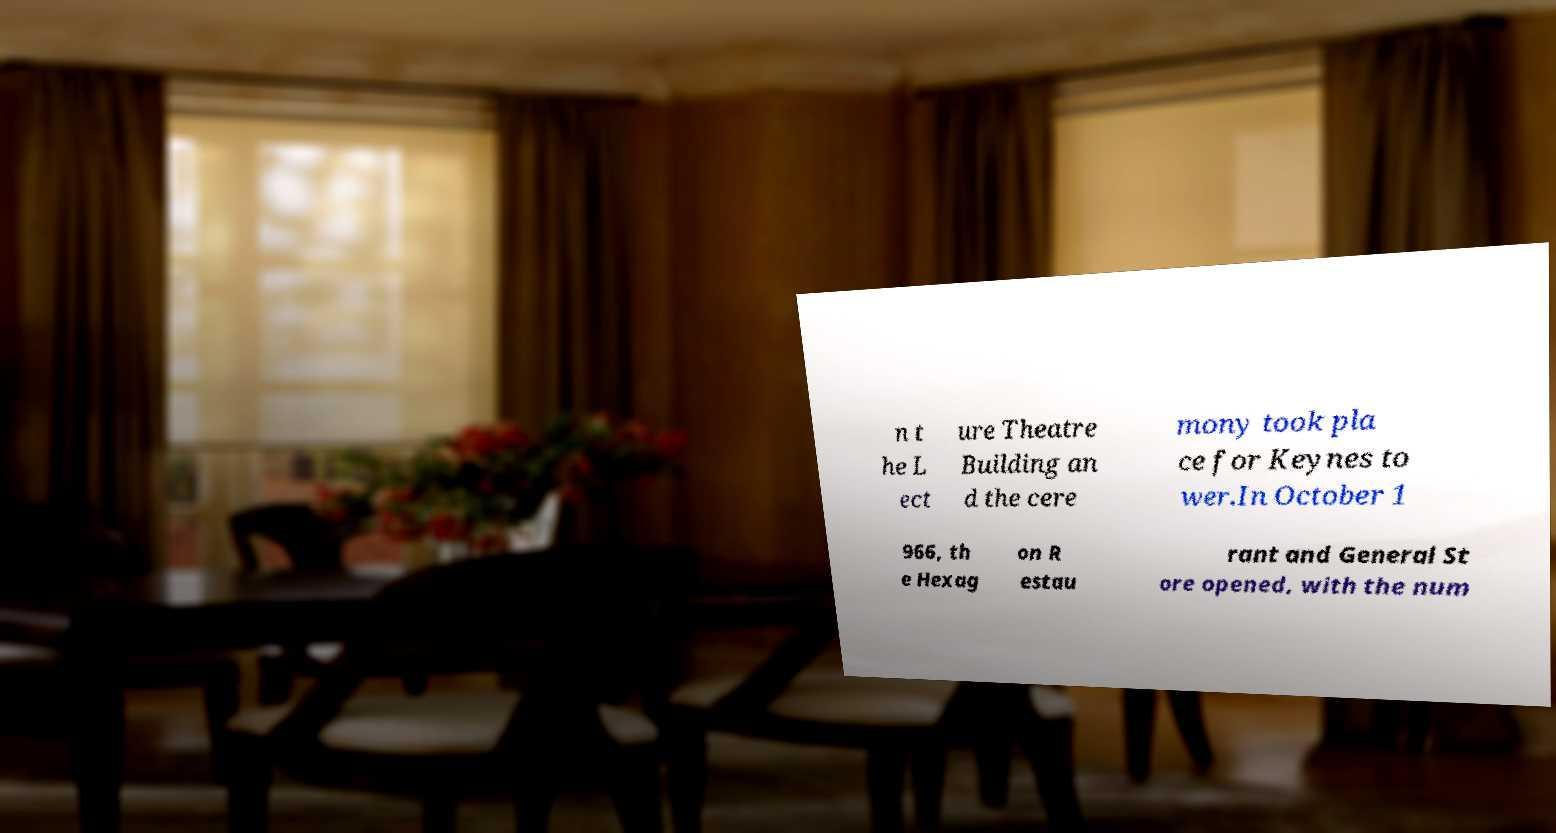Can you read and provide the text displayed in the image?This photo seems to have some interesting text. Can you extract and type it out for me? n t he L ect ure Theatre Building an d the cere mony took pla ce for Keynes to wer.In October 1 966, th e Hexag on R estau rant and General St ore opened, with the num 